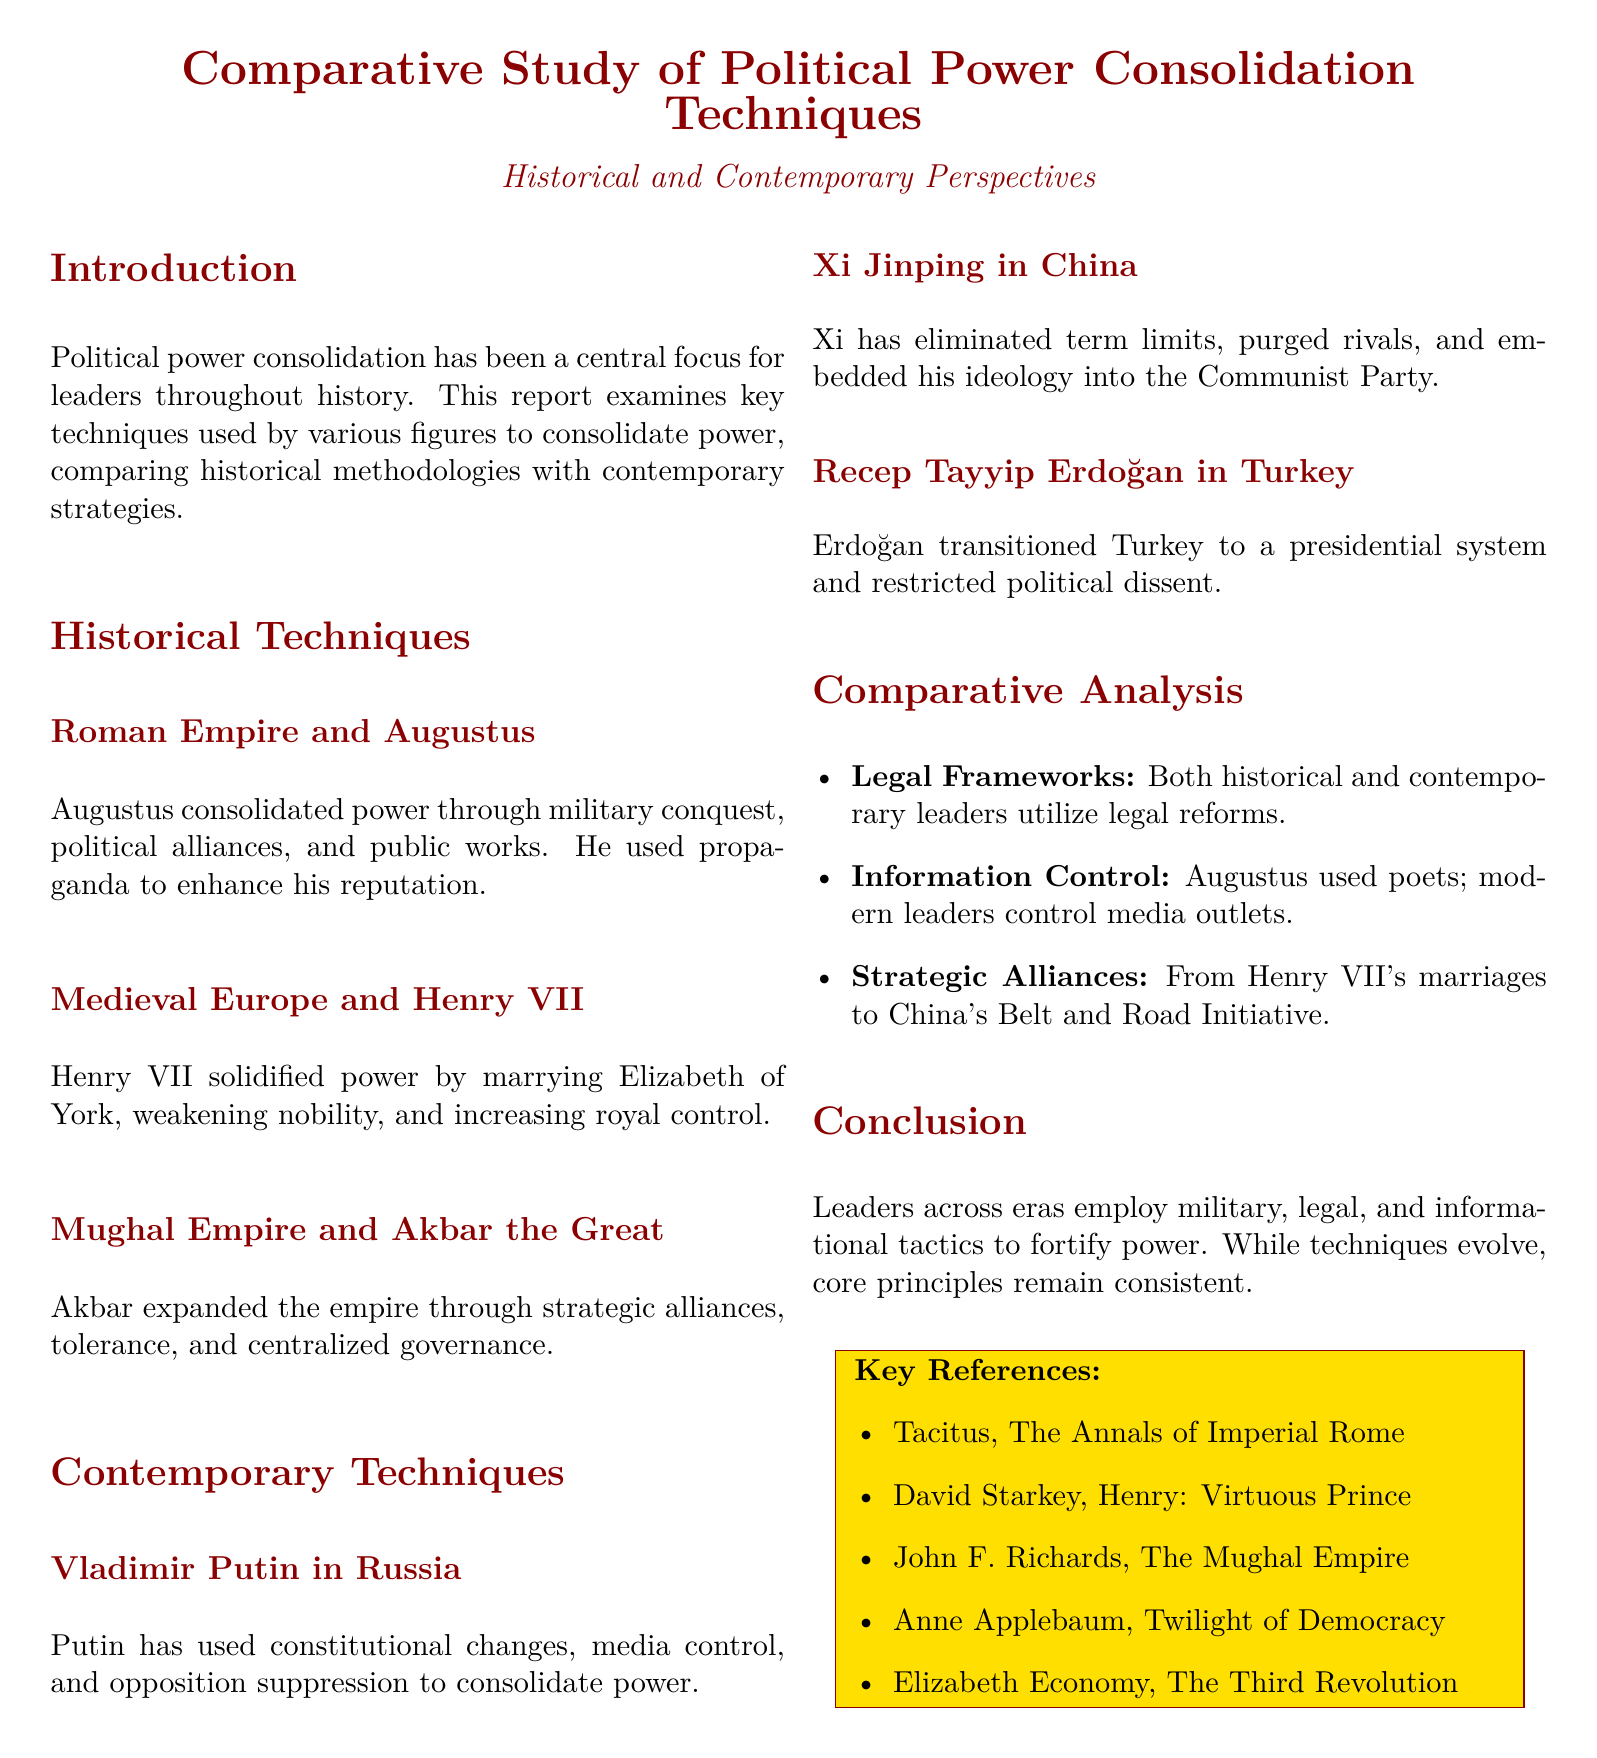What techniques did Augustus use to consolidate power? Augustus consolidated power through military conquest, political alliances, and public works as mentioned in the Historical Techniques section.
Answer: military conquest, political alliances, and public works Who was the ruler associated with the Mughal Empire? The section on Historical Techniques identifies Akbar the Great as the ruler associated with the Mughal Empire.
Answer: Akbar the Great Which leader transitioned Turkey to a presidential system? The Contemporary Techniques section specifies Erdoğan as the leader who transitioned Turkey to a presidential system.
Answer: Erdoğan What is one historical technique used for power consolidation? The Comparative Analysis mentions that historical leaders utilize legal reforms as one method of power consolidation.
Answer: legal reforms What modern technique does Xi Jinping use for power consolidation? The document states that Xi Jinping has eliminated term limits as a contemporary technique for power consolidation.
Answer: eliminated term limits How does the document categorize itself? The title and introduction of the document indicate that it is a comparative study of political power consolidation techniques.
Answer: comparative study What does the section on Comparative Analysis include about information control? The Comparative Analysis outlines that Augustus used poets as a form of information control, while modern leaders control media outlets.
Answer: poets, media outlets Who is one of the key references listed in the document? The Key References section lists Tacitus as one of the key references for the report.
Answer: Tacitus 